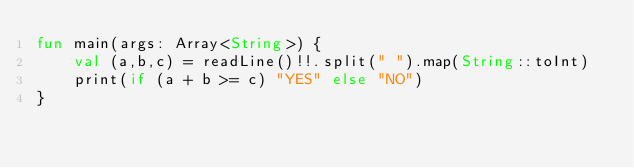Convert code to text. <code><loc_0><loc_0><loc_500><loc_500><_Kotlin_>fun main(args: Array<String>) {
    val (a,b,c) = readLine()!!.split(" ").map(String::toInt)
    print(if (a + b >= c) "YES" else "NO")
}</code> 